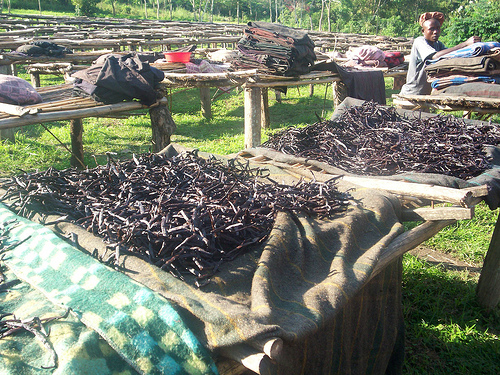<image>
Is the table to the left of the table? No. The table is not to the left of the table. From this viewpoint, they have a different horizontal relationship. 